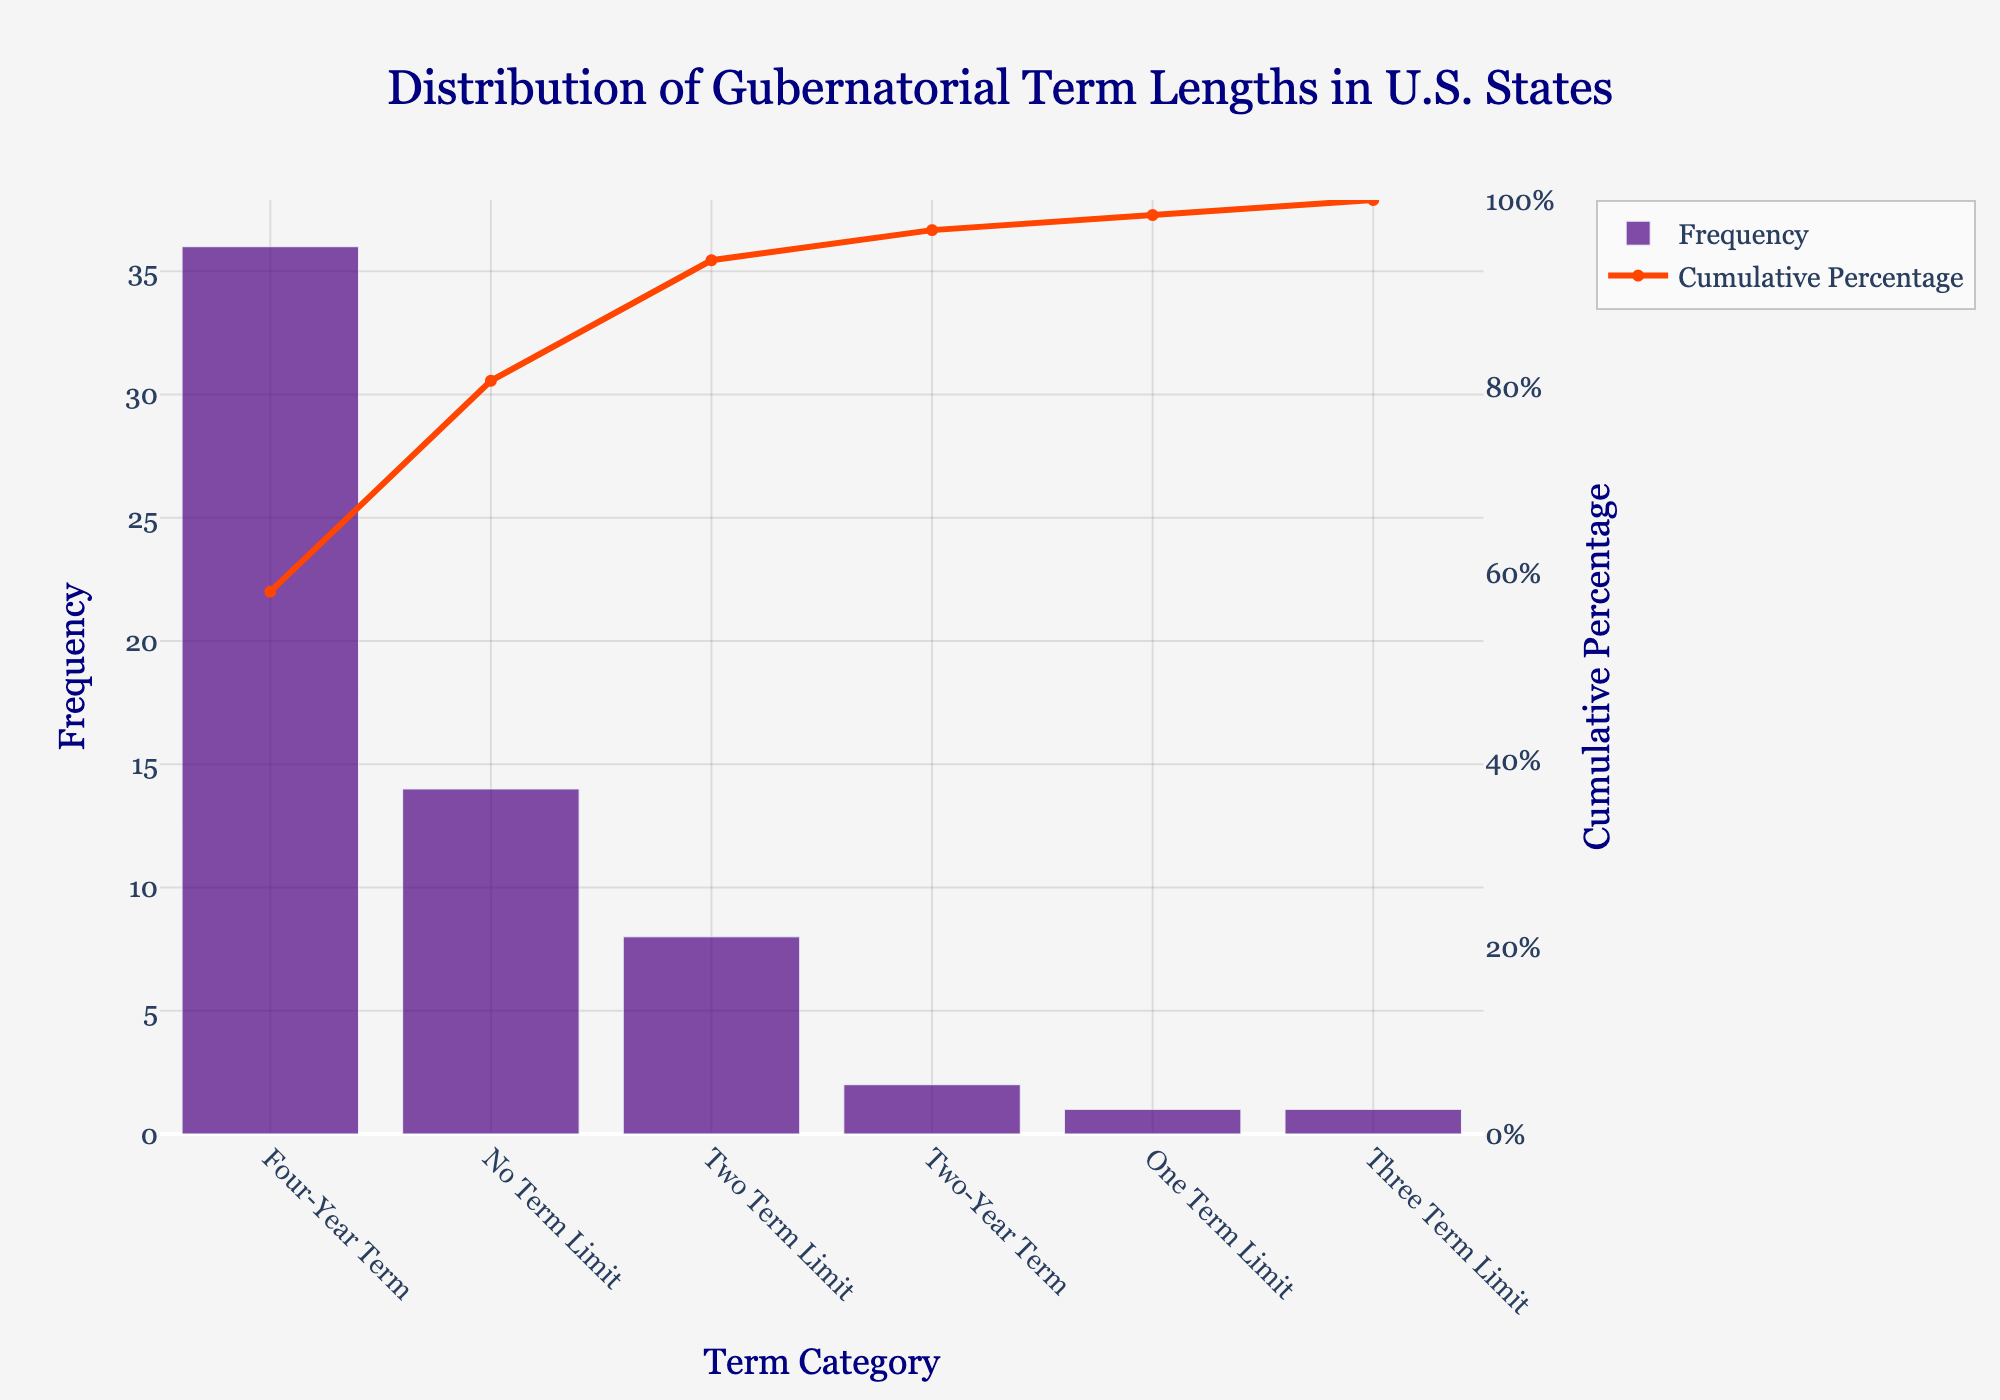What is the title of the chart? The title of the chart is located at the top and reads 'Distribution of Gubernatorial Term Lengths in U.S. States'.
Answer: 'Distribution of Gubernatorial Term Lengths in U.S. States' How many states have a four-year term length? To find the number of states with a four-year term, look at the bar labeled 'Four-Year Term' on the x-axis and check the height of the bar on the y-axis.
Answer: 36 What is the cumulative percentage for the 'No Term Limit' category? Locate the 'No Term Limit' label on the x-axis and follow the line trace up to the corresponding y-axis on the right representing cumulative percentage.
Answer: 88% Which term category has the lowest frequency? Identify the shortest bar in the chart. The lowest bar represents the 'Two-Year Term' category.
Answer: 'Two-Year Term' What's the cumulative percentage after accounting for 'Four-Year Term' and 'No Term Limit' categories? Add the frequencies for 'Four-Year Term' (36) and 'No Term Limit' (14), then calculate their cumulative frequency (36 + 14 = 50). Check which cumulative percentage value aligns with a frequency of 50.
Answer: 88% Which term categories combine to meet or exceed a cumulative percentage of 90%? Look sequentially through the bars from highest to lowest frequency, adding cumulative percentages until you reach or exceed 90%. The ('Four-Year Term', 'No Term Limit', and 'Two Term Limit') categories together reach 94%.
Answer: 'Four-Year Term', 'No Term Limit', 'Two Term Limit' How does the frequency of 'One Term Limit' compare to 'Three Term Limit'? Compare the heights of the bars for 'One Term Limit' and 'Three Term Limit'. Both bars represent a frequency of 1, so they are equal.
Answer: Equal What percentage of states have at least a four-year term length? Combine the frequencies of term lengths equal to or more than four years (36 + 14 + 1 + 8 + 1 = 60) and divide by the total frequency (60). Multiply this fraction by 100 to convert to a percentage. (60/62) * 100 = 96.77%
Answer: 96.77% Which term category contributes the most to the cumulative percentage line? The longest bar contributes the most to the cumulative percentage, which is the 'Four-Year Term' category.
Answer: 'Four-Year Term' What is the term length category directly contributing to a cumulative percentage exceeding 90%? Trace the cumulative percentage line to where it crosses 90%, and look at the corresponding term length category on the x-axis, which is 'Two Term Limit'.
Answer: 'Two Term Limit' 